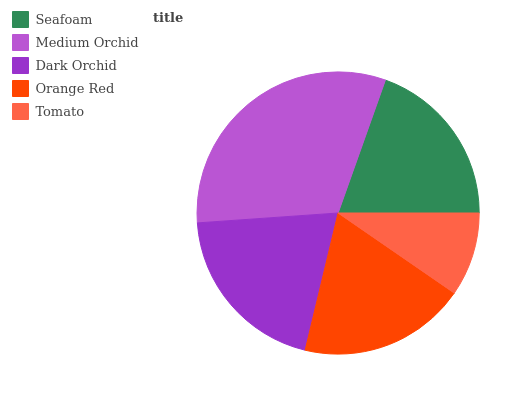Is Tomato the minimum?
Answer yes or no. Yes. Is Medium Orchid the maximum?
Answer yes or no. Yes. Is Dark Orchid the minimum?
Answer yes or no. No. Is Dark Orchid the maximum?
Answer yes or no. No. Is Medium Orchid greater than Dark Orchid?
Answer yes or no. Yes. Is Dark Orchid less than Medium Orchid?
Answer yes or no. Yes. Is Dark Orchid greater than Medium Orchid?
Answer yes or no. No. Is Medium Orchid less than Dark Orchid?
Answer yes or no. No. Is Seafoam the high median?
Answer yes or no. Yes. Is Seafoam the low median?
Answer yes or no. Yes. Is Tomato the high median?
Answer yes or no. No. Is Dark Orchid the low median?
Answer yes or no. No. 